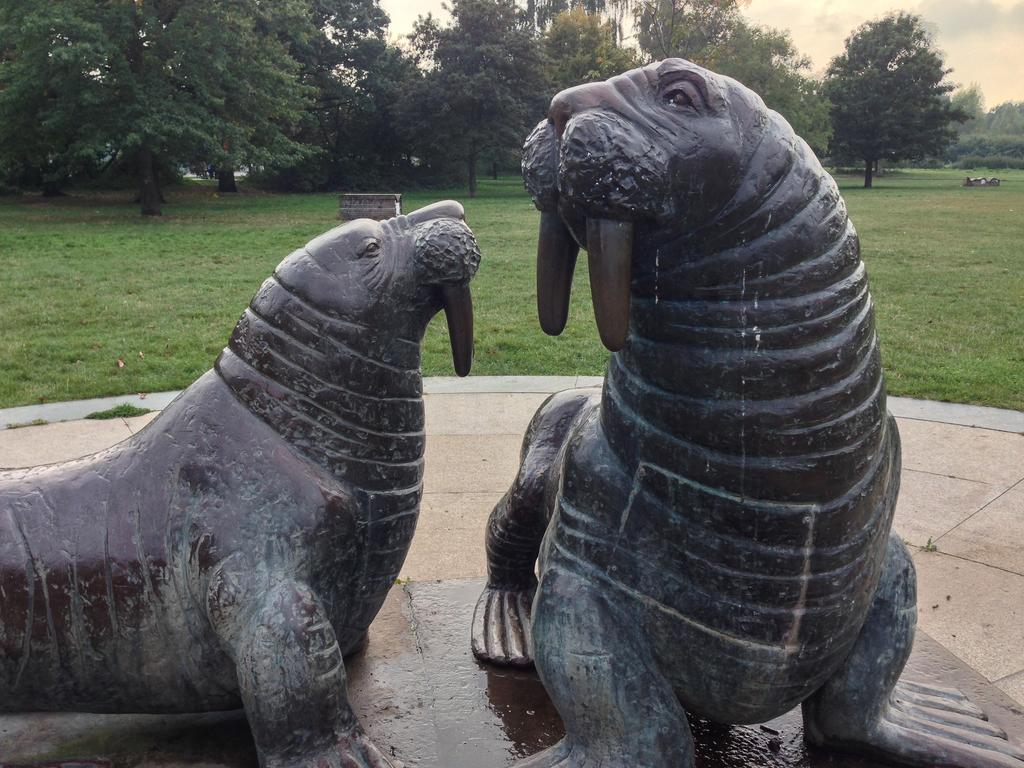What type of animals are depicted as statues in the image? There are statues of walrus on a platform. What can be seen in the background of the image? There is grass, trees, and the sky visible in the background. What type of wire is being used to support the wealth in the image? There is no wire or wealth present in the image; it features statues of walrus on a platform with a grassy background. 